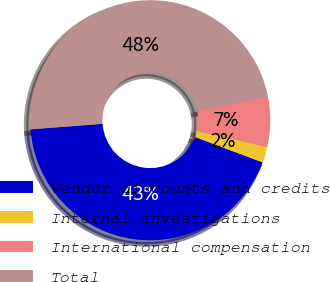Convert chart to OTSL. <chart><loc_0><loc_0><loc_500><loc_500><pie_chart><fcel>Vendor discounts and credits<fcel>Internal investigations<fcel>International compensation<fcel>Total<nl><fcel>43.08%<fcel>2.13%<fcel>6.73%<fcel>48.06%<nl></chart> 